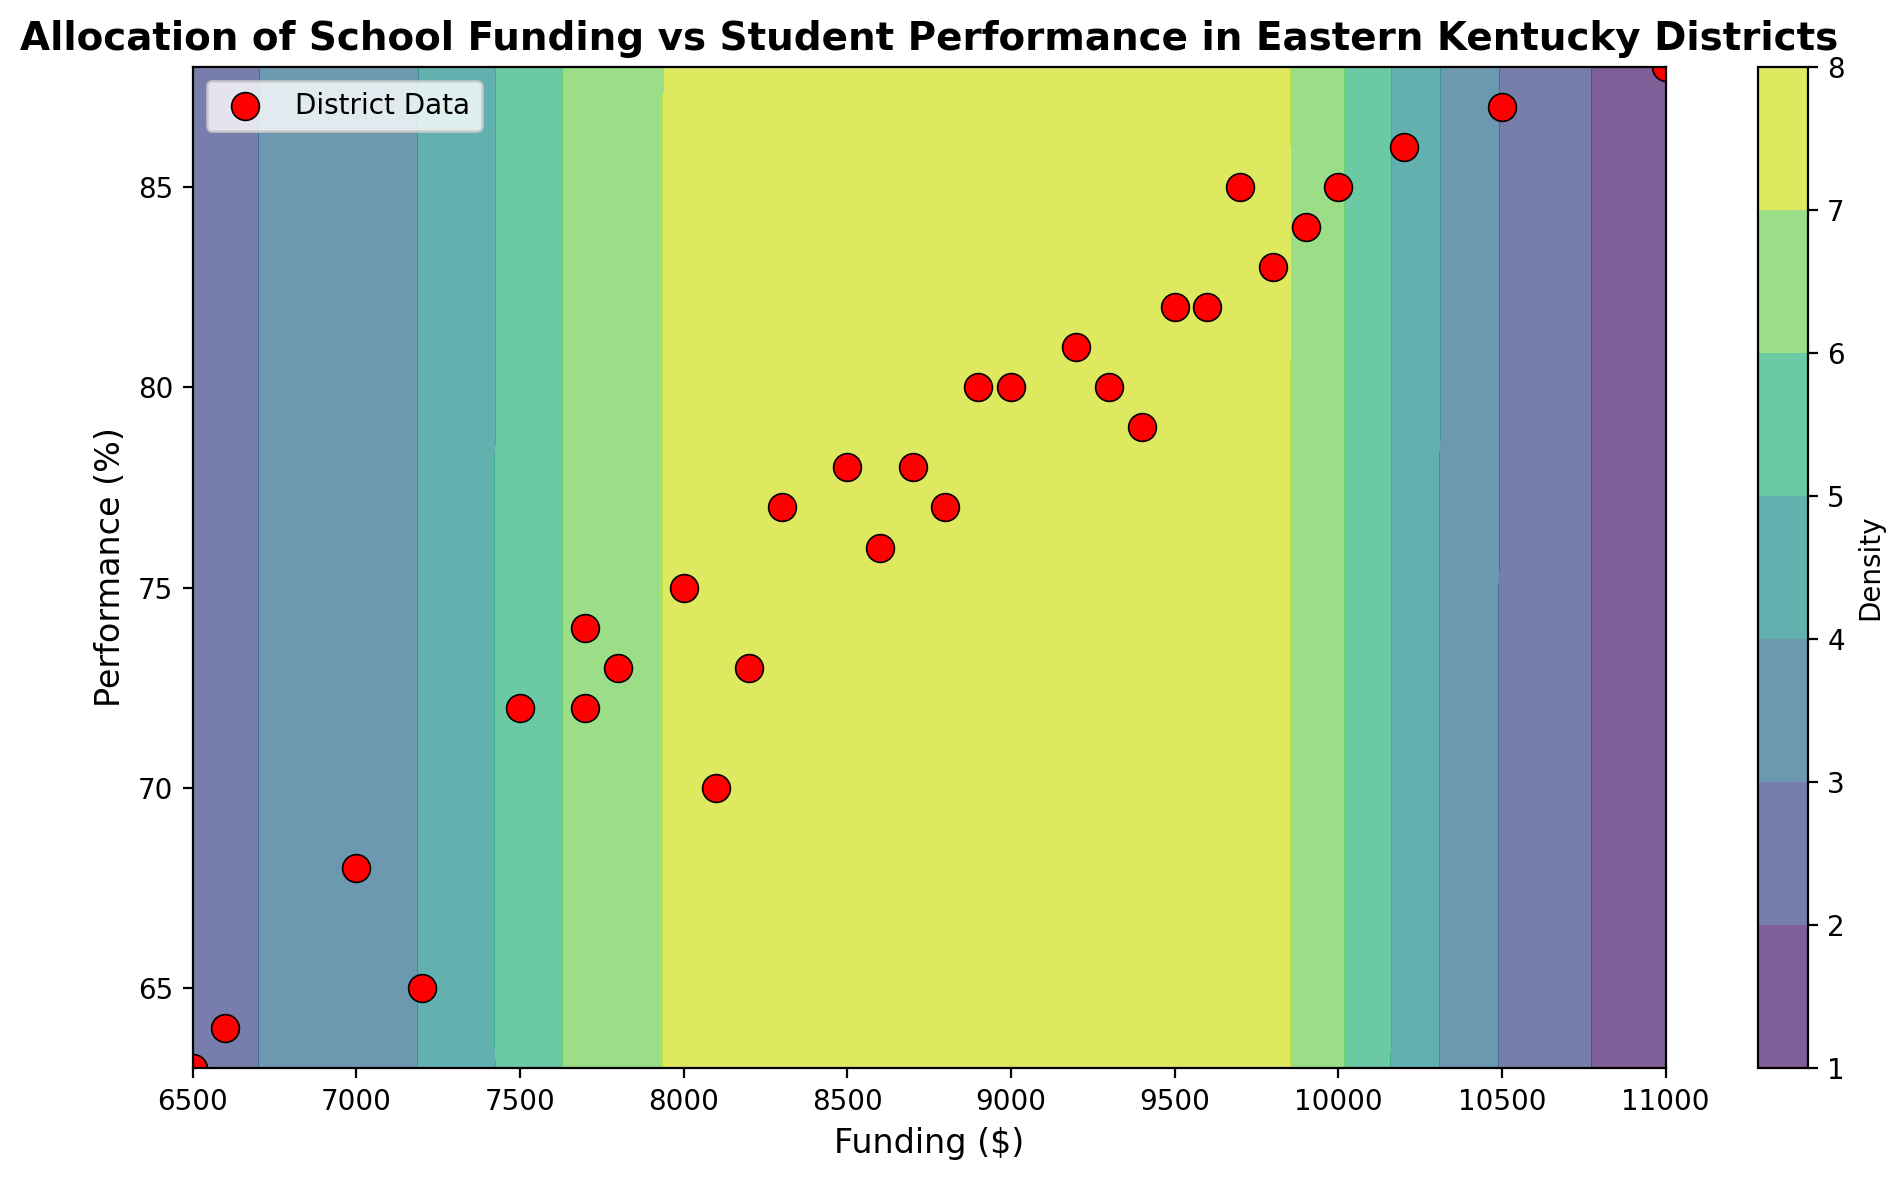What's the relationship between Funding and Performance in the contour plot? In the contour plot, there seems to be an upward trend indicating that as the funding increases, the performance also improves. This is visible from the denser and higher-value contours at higher funding levels.
Answer: Positive correlation Which district has the highest student performance, and what is its corresponding funding level? By referring to the scattered red points, the district with the highest performance is District 6 with a performance level of 88%. The corresponding funding level for this district is $11,000.
Answer: District 6, $11,000 What's the average funding level across all districts shown on the contour plot? Sum the funding for all districts (8000 + 8500 + 9500 + 9000 + 10000 + 11000 + 7500 + 7000 + 9200 + 8800 + 9400 + 9600 + 8100 + 8200 + 9300 + 9900 + 10200 + 7200 + 7700 + 9800 + 10500 + 6500 + 9700 + 8300 + 8700 + 6600 + 7700 + 8900 + 8600 + 7800) which is 260,400, then divide by the number of districts (30). The average funding is 260,400 / 30 = 8680.
Answer: $8,680 Which district has the lowest funding but still manages a performance above the average performance level? The average performance level can be approximated from the data; most performances hover around the mid-70s. District 19 has a funding of $7,700 and a performance of 74, which is above the approximated average.
Answer: District 19 Is there any region on the contour plot indicating both high funding and low performance? Examining the density contours and scattered red points, there doesn’t seem to be any region where high funding correlates with notably low performance. High funding generally corresponds to higher performance.
Answer: No Which district appears to be the most efficient in terms of getting a high performance with relatively low funding? District 9 with a performance of 81% and a funding level of $9200 shows relatively high performance given its lower funding compared to other similar performing districts.
Answer: District 9 Do you observe any outliers in terms of performance among the districts with similar funding levels? District 18 stands out as an outlier with relatively low performance (65%) when compared to other districts with similar funding levels around $7,200.
Answer: District 18 Based on the contour plot, what can be inferred about the performance range for districts receiving between $9000 and $10,000 in funding? Districts in this funding range typically exhibit performance levels between 77% and 85%, indicating good to very good student outcomes.
Answer: 77% to 85% How does District 21 compare to District 26 in terms of both funding and performance? District 21 has higher funding ($10,500) and higher performance (87%) than District 26, which has lower funding ($6,600) and lower performance (64%).
Answer: District 21 has higher funding and performance What is the overall trend of student performance as funding decreases below $7,000? As funding decreases below $7,000, there is a visible trend of lower performance, with the lowest funding correlating with some of the lowest performance levels visible on the contour plot.
Answer: Decreasing performance 